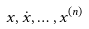<formula> <loc_0><loc_0><loc_500><loc_500>x , \dot { x } , \dots , x ^ { ( n ) }</formula> 